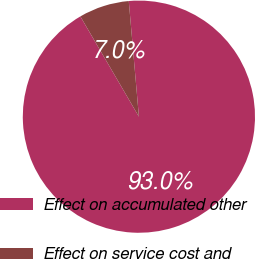<chart> <loc_0><loc_0><loc_500><loc_500><pie_chart><fcel>Effect on accumulated other<fcel>Effect on service cost and<nl><fcel>92.98%<fcel>7.02%<nl></chart> 